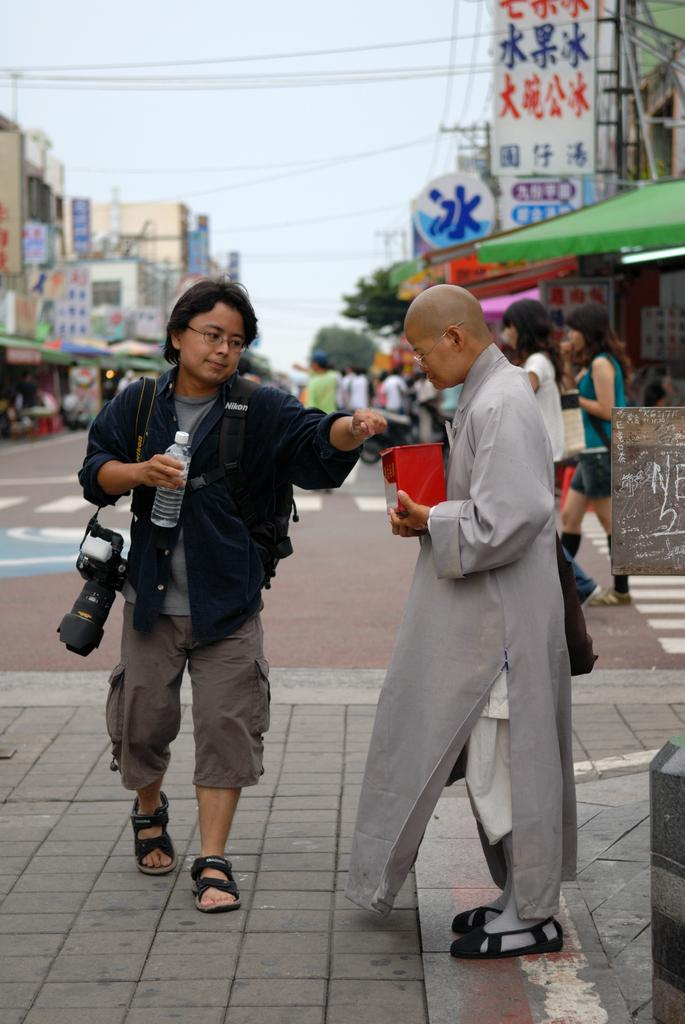What is the person holding in the image? The person is holding a bottle. What else is the person carrying in the image? The person is carrying a camera. What else is the person holding in the image? The person is holding a box. What can be seen in the background of the image? There are buildings visible in the image. What is visible above the buildings in the image? The sky is visible in the image. Are there any other people present in the image? Yes, there are other people standing on the road. What type of flame can be seen coming from the camera in the image? There is no flame present in the image, and the camera is not producing any flames. 